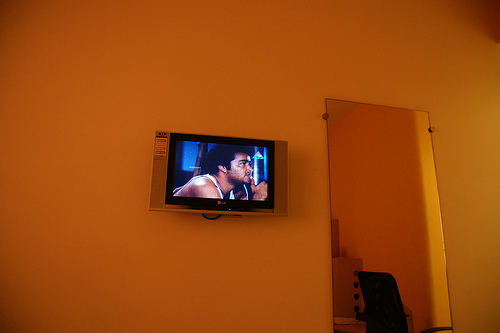<image>Where is the art? It is unknown where the art is located. It may be on the wall or it might not be present. Where is the art? The art can be seen on the wall. 